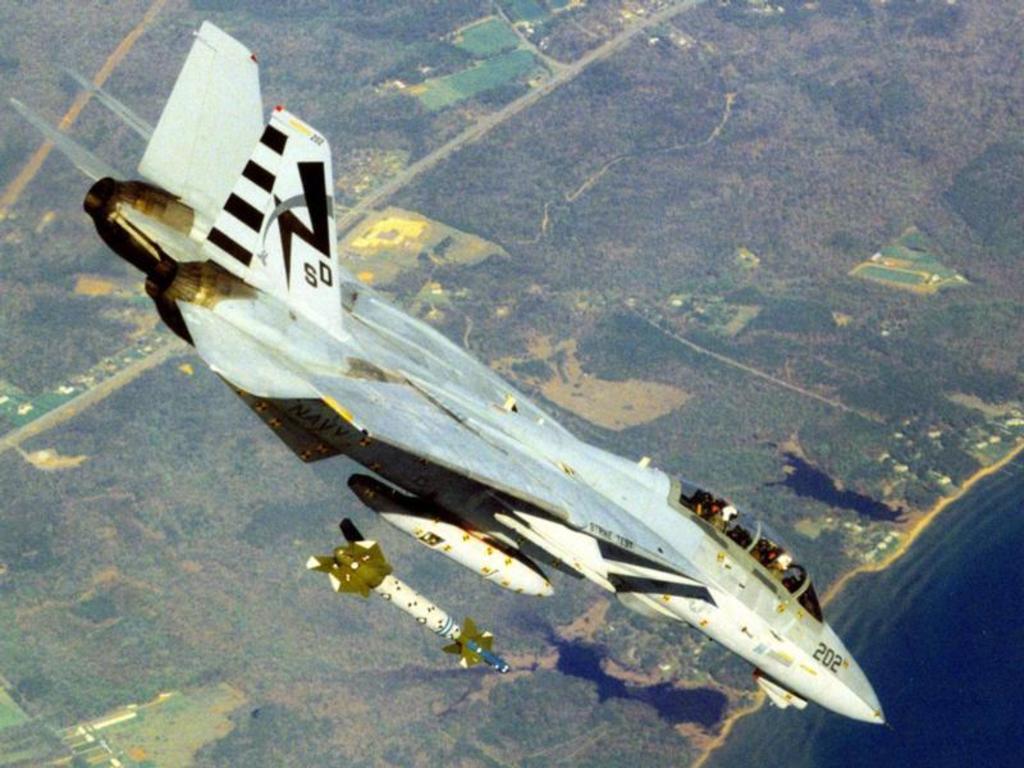What number is on the nose of this aircraft?
Provide a succinct answer. 202. 